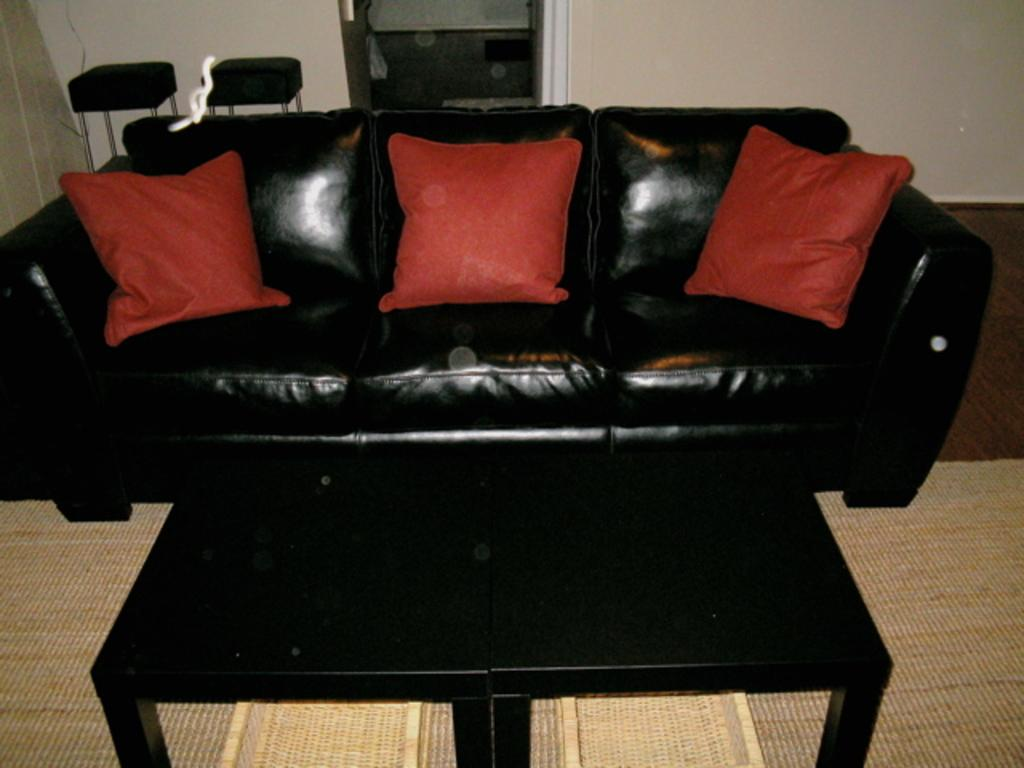What type of furniture is present in the image? There is a table and a black color sofa with red color pillows in the image. How many stools are visible in the image? There are two stools in the image. What can be seen in the background of the image? There is a wall in the background of the image. What type of grass is growing on the country in the image? There is no grass or country present in the image; it features a table, a sofa, and stools. What story is being told by the people in the image? There are no people present in the image, so no story can be observed. 